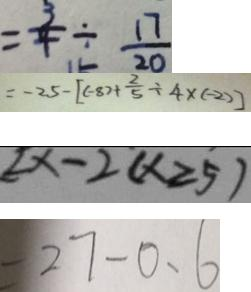Convert formula to latex. <formula><loc_0><loc_0><loc_500><loc_500>= \frac { 3 } { 4 } \div \frac { 1 7 } { 2 0 } 
 = - 2 5 - [ ( - 8 ) + \frac { 2 } { 5 } \div 4 ( - 2 ) ] 
 [ x - 2 ( x \geqslant 5 ) 
 = 2 7 - 0 . 6</formula> 